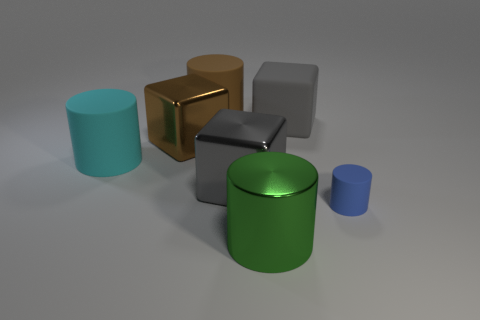Are there fewer tiny red metallic objects than green shiny cylinders?
Your answer should be compact. Yes. The other small object that is the same shape as the green metallic thing is what color?
Make the answer very short. Blue. What color is the cylinder that is made of the same material as the brown block?
Ensure brevity in your answer.  Green. What number of cubes have the same size as the brown cylinder?
Your response must be concise. 3. What material is the brown block?
Provide a succinct answer. Metal. Is the number of brown rubber cylinders greater than the number of large red metallic cylinders?
Ensure brevity in your answer.  Yes. Do the big gray metal thing and the large brown metallic object have the same shape?
Keep it short and to the point. Yes. There is a large matte cube behind the green cylinder; is its color the same as the large metal block that is to the right of the brown metal thing?
Offer a very short reply. Yes. Is the number of gray matte cubes that are left of the cyan matte cylinder less than the number of gray things that are to the left of the large green shiny object?
Offer a terse response. Yes. What shape is the object in front of the small matte thing?
Make the answer very short. Cylinder. 